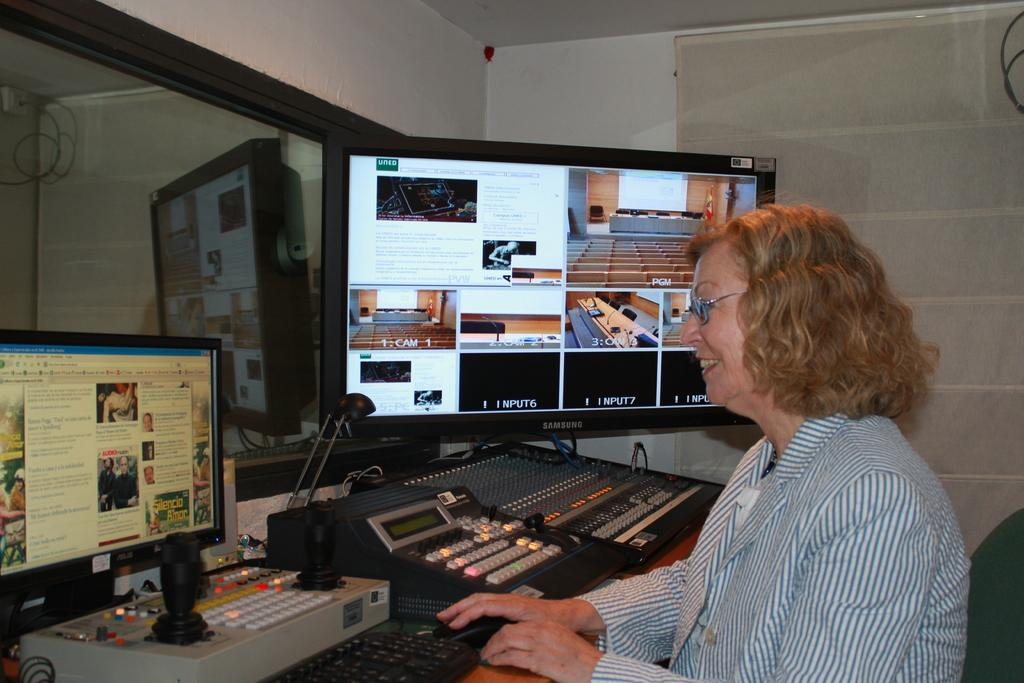<image>
Give a short and clear explanation of the subsequent image. a lady is smiling at a small monitor with a large monitor beside her that is labeled with the cameras it is watching 